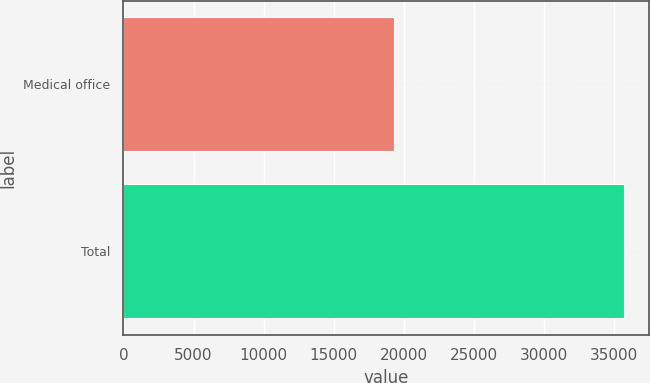Convert chart to OTSL. <chart><loc_0><loc_0><loc_500><loc_500><bar_chart><fcel>Medical office<fcel>Total<nl><fcel>19279<fcel>35713<nl></chart> 